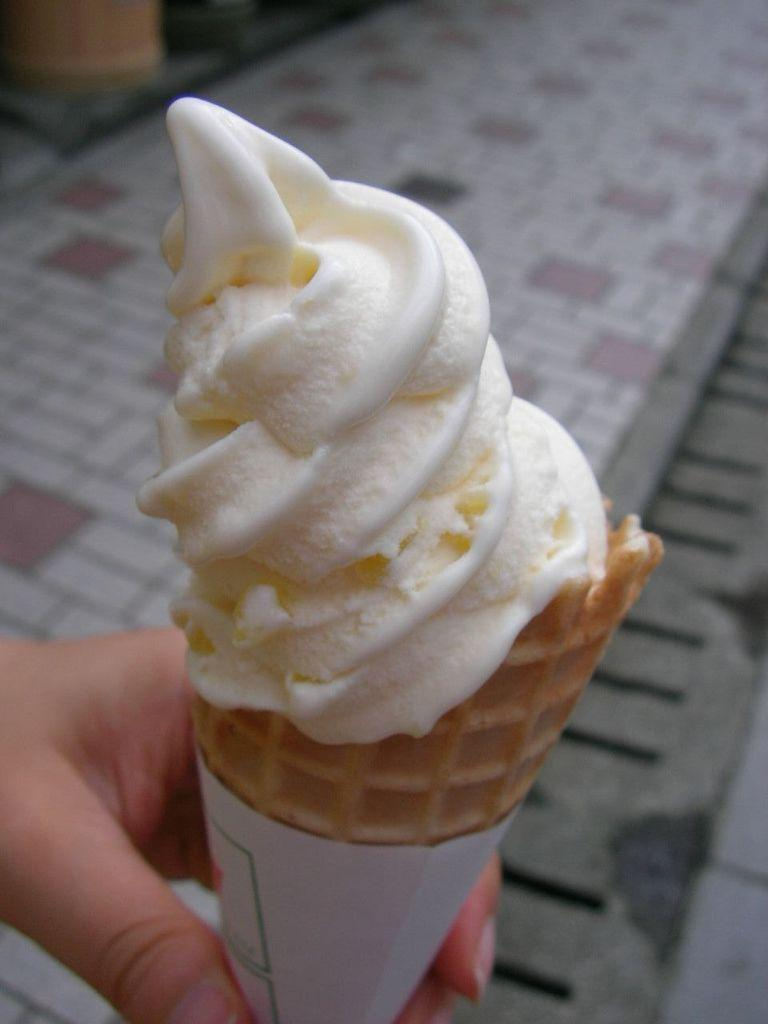What is the main subject in the foreground of the image? There is a person in the foreground of the image. What is the person holding in the image? The person is holding an ice cream. What can be seen in the background of the image? There is a walkway in the background of the image. How does the person generate power for the ice cream in the image? The image does not generate power for the ice cream in the image, as it is not an electronic device. 